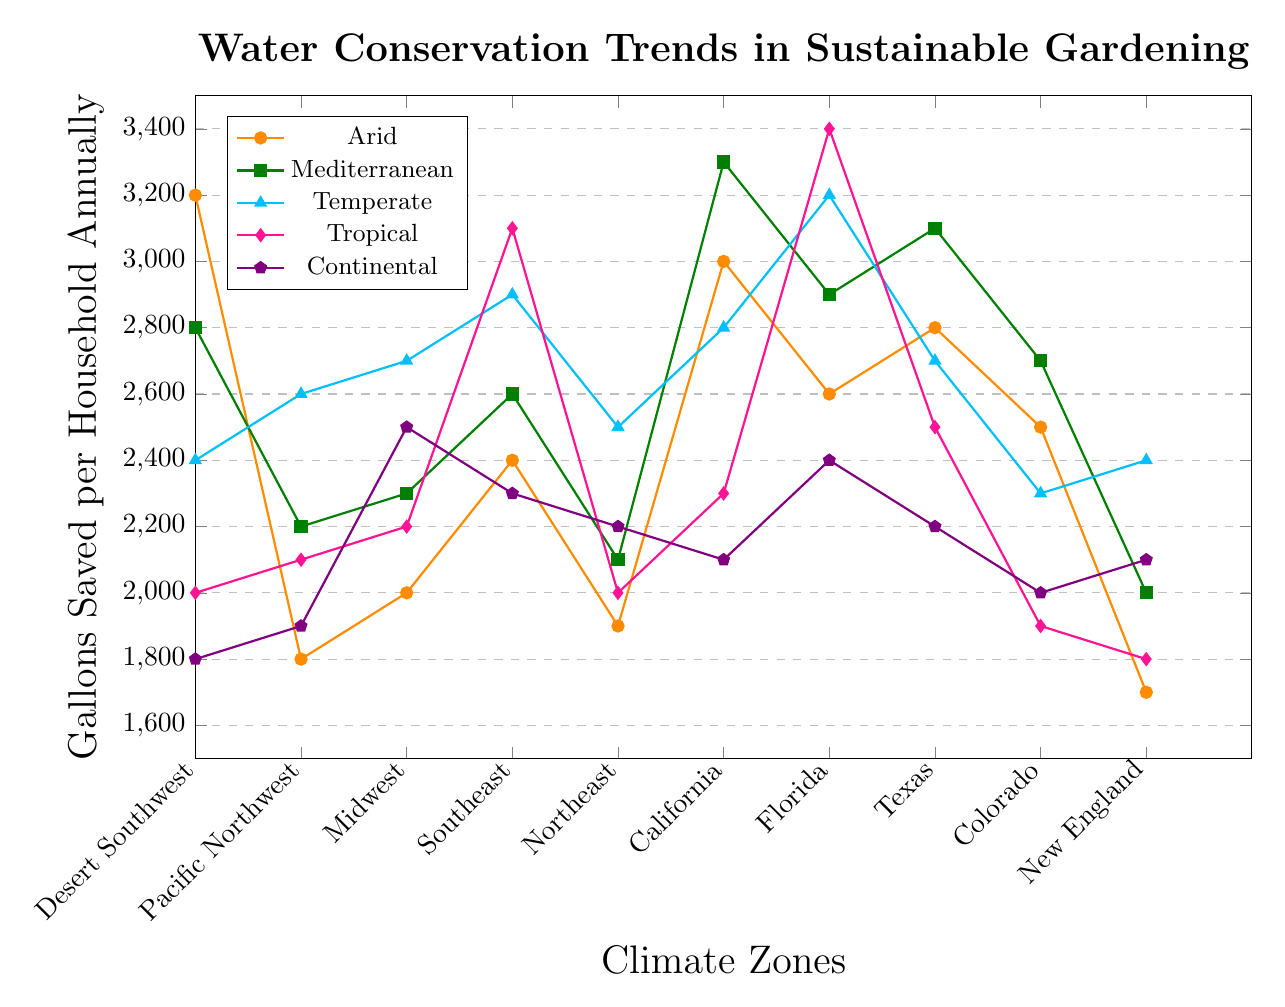What climate zone has the highest gallons saved in tropical climate? The tropical line is represented by the diamond marker. The highest value for the tropical climate is in Florida, which has a savings of 3400 gallons.
Answer: Florida Which climate zone shows the lowest water conservation in arid climate? The arid line is represented by the circle marker. The lowest value for the arid climate is in New England, which has a savings of 1700 gallons.
Answer: New England Compare the water savings for Mediterranean climate between Southeast and Pacific Northwest regions. The Mediterranean line is represented by the square marker. The value for the Southeast is 2600 gallons, and for the Pacific Northwest, it is 2200 gallons. 2600 is greater than 2200.
Answer: Southeast What is the total water savings for the continental climate across all climate zones? The continental line is represented by the pentagon marker. Sum the values for each region: 1800 (Desert Southwest) + 1900 (Pacific Northwest) + 2500 (Midwest) + 2300 (Southeast) + 2200 (Northeast) + 2100 (California) + 2400 (Florida) + 2200 (Texas) + 2000 (Colorado) + 2100 (New England). So, the total is 22500 gallons.
Answer: 22500 Which climate zone shows the most consistent water savings across different climates (i.e., smallest range in values)? To identify the most consistent zone, we need to look at the difference between the highest and lowest values within each zone. For each climate zone: 
- Desert Southwest: max(3200, 2800, 2400, 2000, 1800) - min(3200, 2800, 2400, 2000, 1800) = 3200 - 1800 = 1400
- Pacific Northwest: max(1800, 2200, 2600, 2100, 1900) - min(1800, 2200, 2600, 2100, 1900) = 2600 - 1800 = 800
- Midwest: max(2000, 2300, 2700, 2200, 2500) - min(2000, 2300, 2700, 2200, 2500) = 2700 - 2000 = 700
- Southeast: max(2400, 2600, 2900, 3100, 2300) - min(2400, 2600, 2900, 3100, 2300) = 3100 - 2300 = 800
- Northeast: max(1900, 2100, 2500, 2000, 2200) - min(1900, 2100, 2500, 2000, 2200) = 2500 - 1900 = 600
- California: max(3000, 3300, 2800, 2300, 2100) - min(3000, 3300, 2800, 2300, 2100) = 3300 - 2100 = 1200
- Florida: max(2600, 2900, 3200, 3400, 2400) - min(2600, 2900, 3200, 3400, 2400) = 3400 - 2400 = 1000
- Texas: max(2800, 3100, 2700, 2500, 2200) - min(2800, 3100, 2700, 2500, 2200) = 3100 - 2200 = 900
- Colorado: max(2500, 2700, 2300, 1900, 2000) - min(2500, 2700, 2300, 1900, 2000) = 2700 - 1900 = 800
- New England: max(1700, 2000, 2400, 1800, 2100) - min(1700, 2000, 2400, 1800, 2100) = 2400 - 1700 = 700
The Northeast zone has the smallest range in values (600).
Answer: Northeast Which climate zone has the highest average water savings across all climates? Calculate the average for each zone:
- Desert Southwest: (3200 + 2800 + 2400 + 2000 + 1800) / 5 = 2440
- Pacific Northwest: (1800 + 2200 + 2600 + 2100 + 1900) / 5 = 2120
- Midwest: (2000 + 2300 + 2700 + 2200 + 2500) / 5 = 2340
- Southeast: (2400 + 2600 + 2900 + 3100 + 2300) / 5 = 2660
- Northeast: (1900 + 2100 + 2500 + 2000 + 2200) / 5 = 2140
- California: (3000 + 3300 + 2800 + 2300 + 2100) / 5 = 2700
- Florida: (2600 + 2900 + 3200 + 3400 + 2400) / 5 = 2900
- Texas: (2800 + 3100 + 2700 + 2500 + 2200) / 5 = 2660
- Colorado: (2500 + 2700 + 2300 + 1900 + 2000) / 5 = 2280
- New England: (1700 + 2000 + 2400 + 1800 + 2100) / 5 = 2000
So, Florida has the highest average water savings of 2900 gallons.
Answer: Florida 